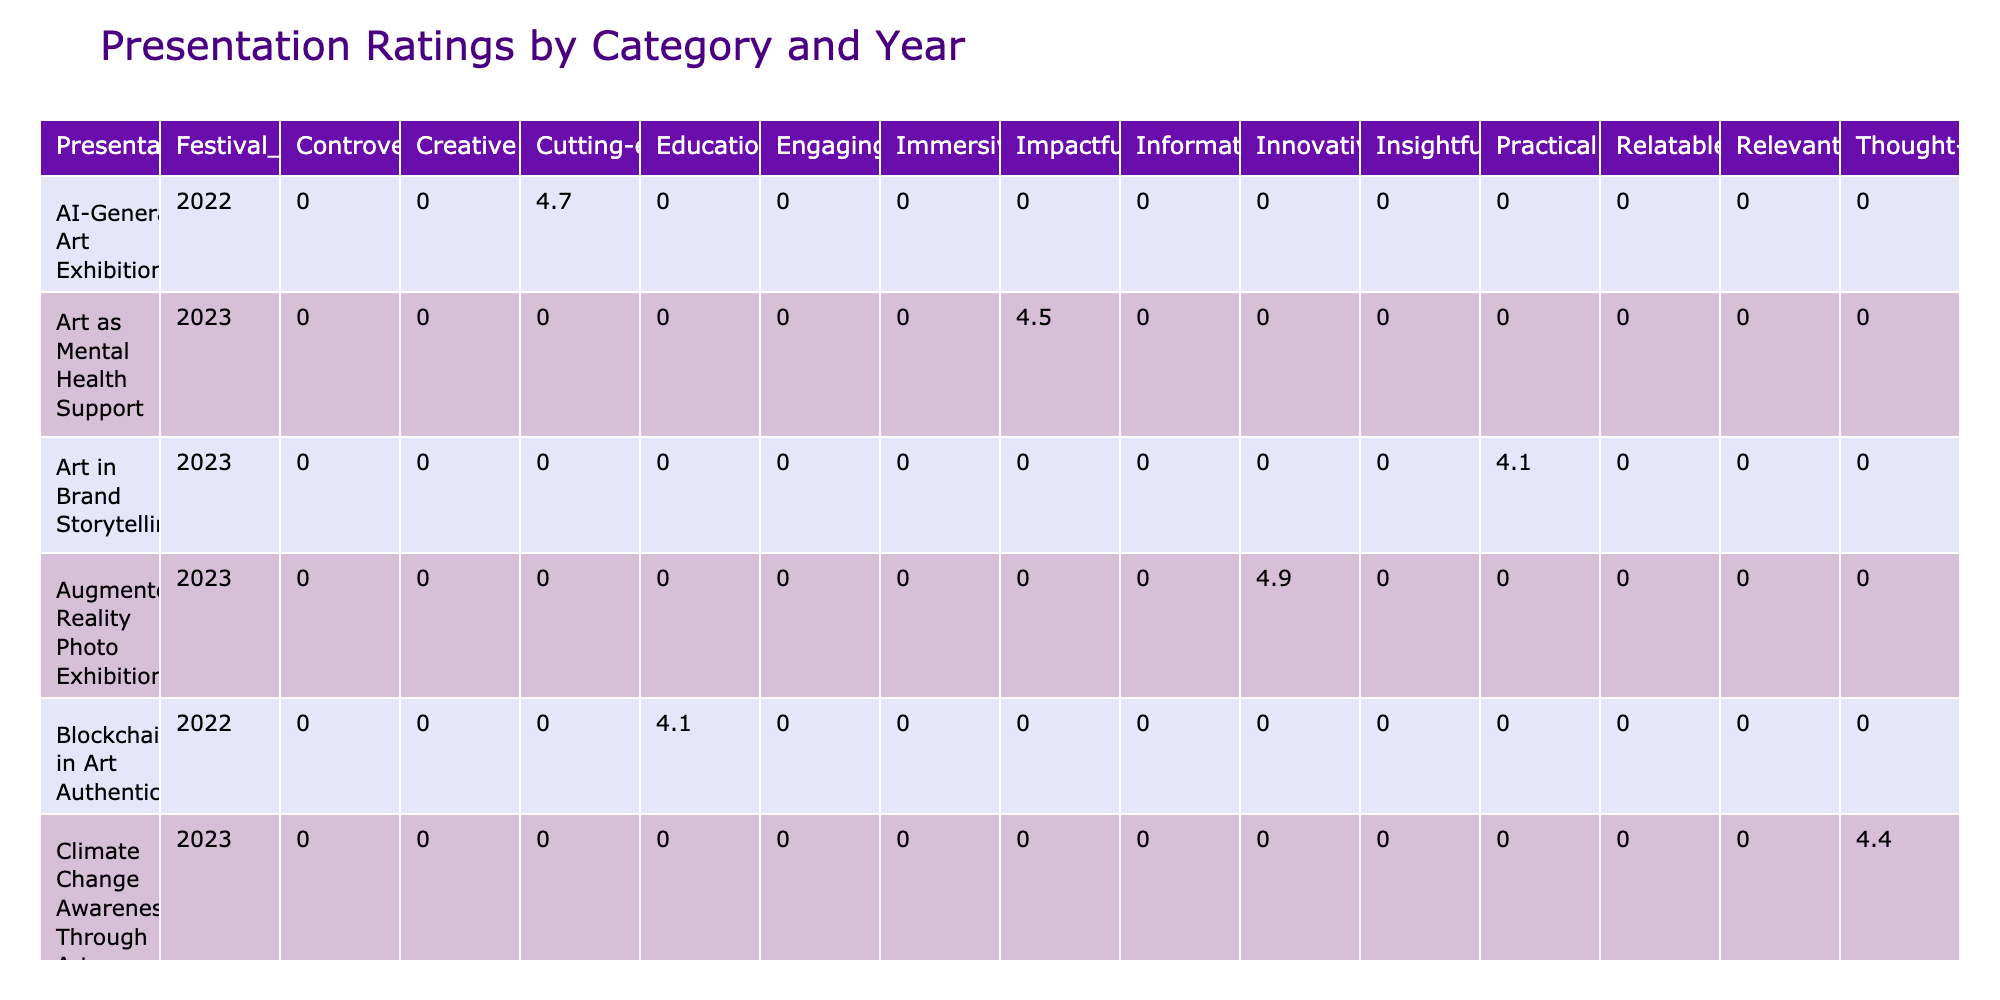What was the highest rating received in the 2023 festival? By examining the ratings for each presentation under the 2023 festival year, "Augmented Reality Photo Exhibition" has the highest rating of 4.9.
Answer: 4.9 Which feedback category had the least rating for any presentation in 2022? The lowest rating in 2022 is 3.9 for the presentation "NFT Marketplace Insights," categorized as "Controversial."
Answer: 3.9 How many presentations had an average rating of 4.5 or higher in 2023? In 2023, there are five presentations that achieved a rating of 4.5 or higher: "Augmented Reality Photo Exhibition" (4.9), "Wearable Tech Art Showcase" (4.6), "Art as Mental Health Support" (4.5), "Sound Art Installation" (4.8), and "Climate Change Awareness Through Art" (4.4). Therefore, the total is five.
Answer: 5 Did any presentation in 2022 receive a rating of 4.8 or higher? Yes, there were two presentations in 2022 that received ratings of 4.8 or higher: "Interactive Installation Showcase" (4.8) and "Augmented Reality Photo Exhibition" (4.9 in 2023). However, only the first one is from 2022.
Answer: Yes What is the difference between the highest and lowest ratings in the 2022 festival? The highest rating is 4.8 for "Interactive Installation Showcase" and the lowest rating is 3.9 for "NFT Marketplace Insights." The difference is calculated as 4.8 - 3.9 = 0.9.
Answer: 0.9 